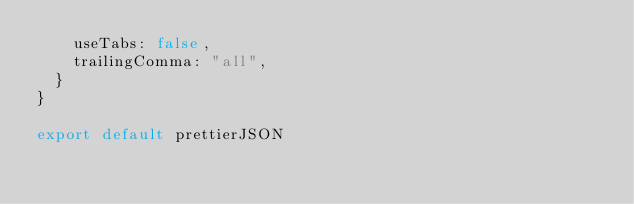<code> <loc_0><loc_0><loc_500><loc_500><_TypeScript_>    useTabs: false,
    trailingComma: "all",
  }
}

export default prettierJSON
</code> 